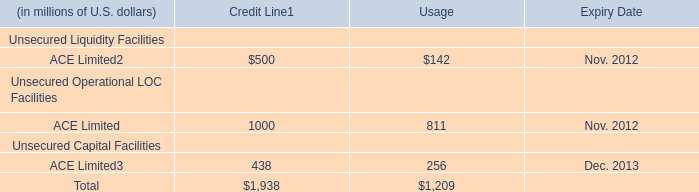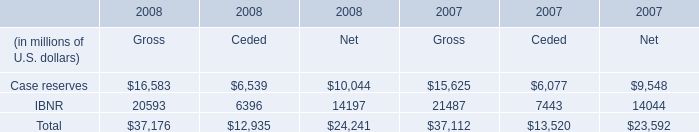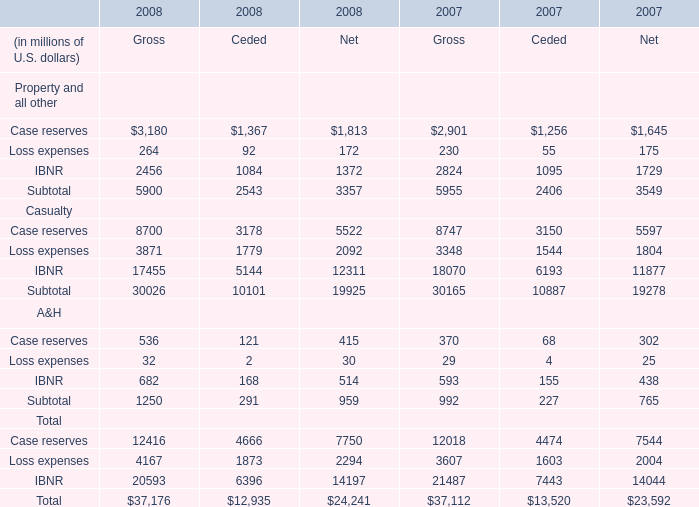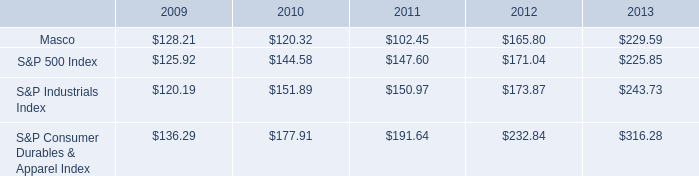If IBNR of A&H of Gross develops with the same growth rate in 2008, what will it reach in 2009? (in million) 
Computations: (682 * (1 + ((682 - 593) / 593)))
Answer: 784.3575. 